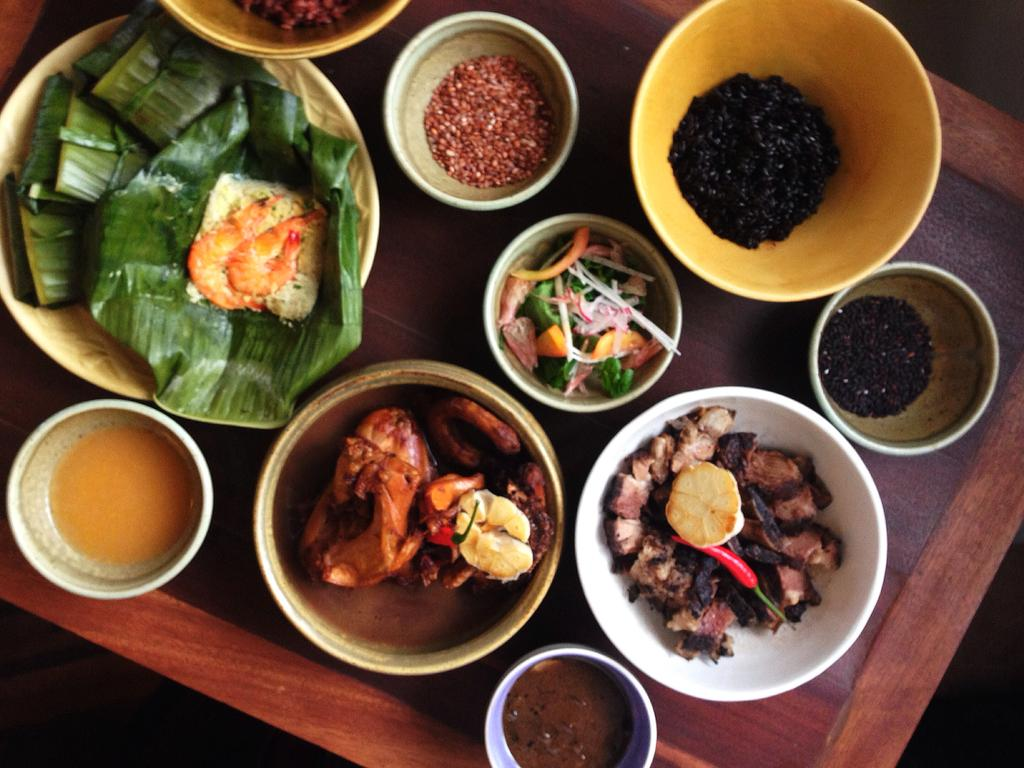What is the main object in the image? There is a tray in the image. What is on the tray? There are cups and bowls on the tray. What is inside the cups and bowls? There are food items in the cups and bowls. What can be seen in the background of the image? The background of the image appears to be black. How much tax is being paid on the gold in the image? There is no gold or mention of tax in the image. 